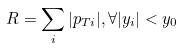Convert formula to latex. <formula><loc_0><loc_0><loc_500><loc_500>R = \sum _ { i } | p _ { T i } | , \forall | y _ { i } | < y _ { 0 }</formula> 